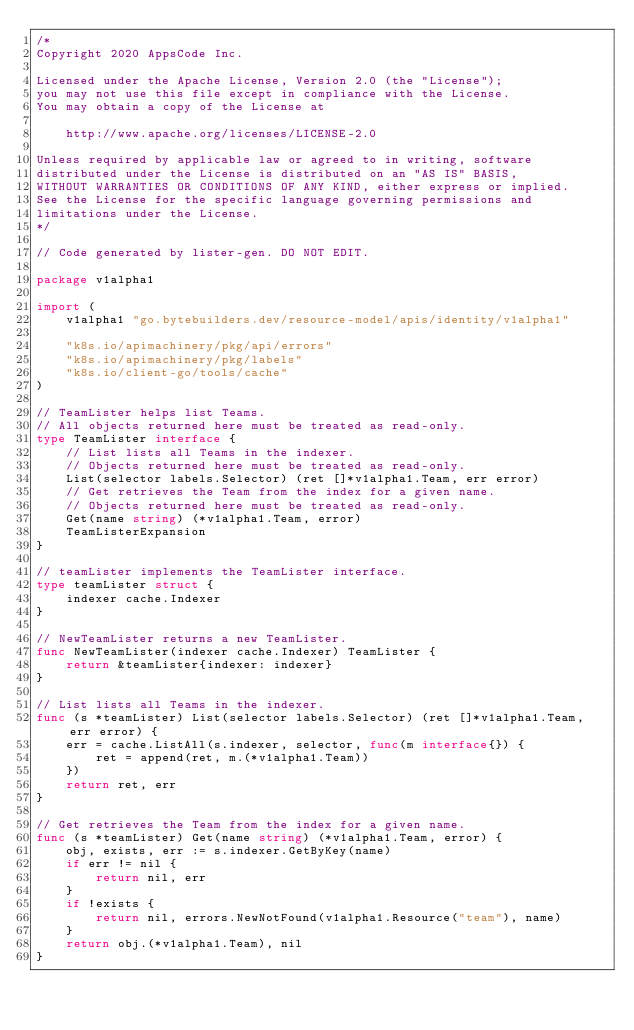<code> <loc_0><loc_0><loc_500><loc_500><_Go_>/*
Copyright 2020 AppsCode Inc.

Licensed under the Apache License, Version 2.0 (the "License");
you may not use this file except in compliance with the License.
You may obtain a copy of the License at

    http://www.apache.org/licenses/LICENSE-2.0

Unless required by applicable law or agreed to in writing, software
distributed under the License is distributed on an "AS IS" BASIS,
WITHOUT WARRANTIES OR CONDITIONS OF ANY KIND, either express or implied.
See the License for the specific language governing permissions and
limitations under the License.
*/

// Code generated by lister-gen. DO NOT EDIT.

package v1alpha1

import (
	v1alpha1 "go.bytebuilders.dev/resource-model/apis/identity/v1alpha1"

	"k8s.io/apimachinery/pkg/api/errors"
	"k8s.io/apimachinery/pkg/labels"
	"k8s.io/client-go/tools/cache"
)

// TeamLister helps list Teams.
// All objects returned here must be treated as read-only.
type TeamLister interface {
	// List lists all Teams in the indexer.
	// Objects returned here must be treated as read-only.
	List(selector labels.Selector) (ret []*v1alpha1.Team, err error)
	// Get retrieves the Team from the index for a given name.
	// Objects returned here must be treated as read-only.
	Get(name string) (*v1alpha1.Team, error)
	TeamListerExpansion
}

// teamLister implements the TeamLister interface.
type teamLister struct {
	indexer cache.Indexer
}

// NewTeamLister returns a new TeamLister.
func NewTeamLister(indexer cache.Indexer) TeamLister {
	return &teamLister{indexer: indexer}
}

// List lists all Teams in the indexer.
func (s *teamLister) List(selector labels.Selector) (ret []*v1alpha1.Team, err error) {
	err = cache.ListAll(s.indexer, selector, func(m interface{}) {
		ret = append(ret, m.(*v1alpha1.Team))
	})
	return ret, err
}

// Get retrieves the Team from the index for a given name.
func (s *teamLister) Get(name string) (*v1alpha1.Team, error) {
	obj, exists, err := s.indexer.GetByKey(name)
	if err != nil {
		return nil, err
	}
	if !exists {
		return nil, errors.NewNotFound(v1alpha1.Resource("team"), name)
	}
	return obj.(*v1alpha1.Team), nil
}
</code> 